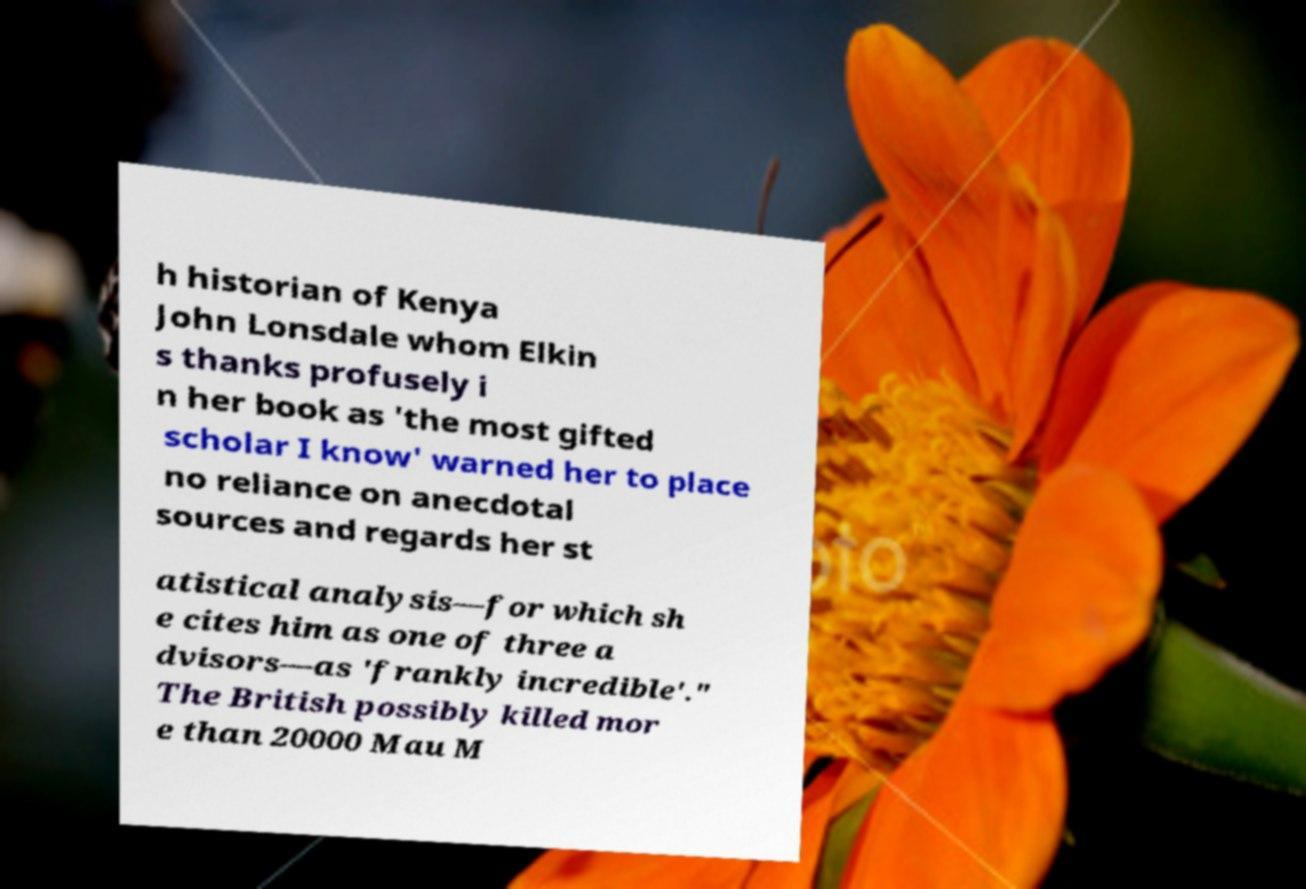Please identify and transcribe the text found in this image. h historian of Kenya John Lonsdale whom Elkin s thanks profusely i n her book as 'the most gifted scholar I know' warned her to place no reliance on anecdotal sources and regards her st atistical analysis—for which sh e cites him as one of three a dvisors—as 'frankly incredible'." The British possibly killed mor e than 20000 Mau M 